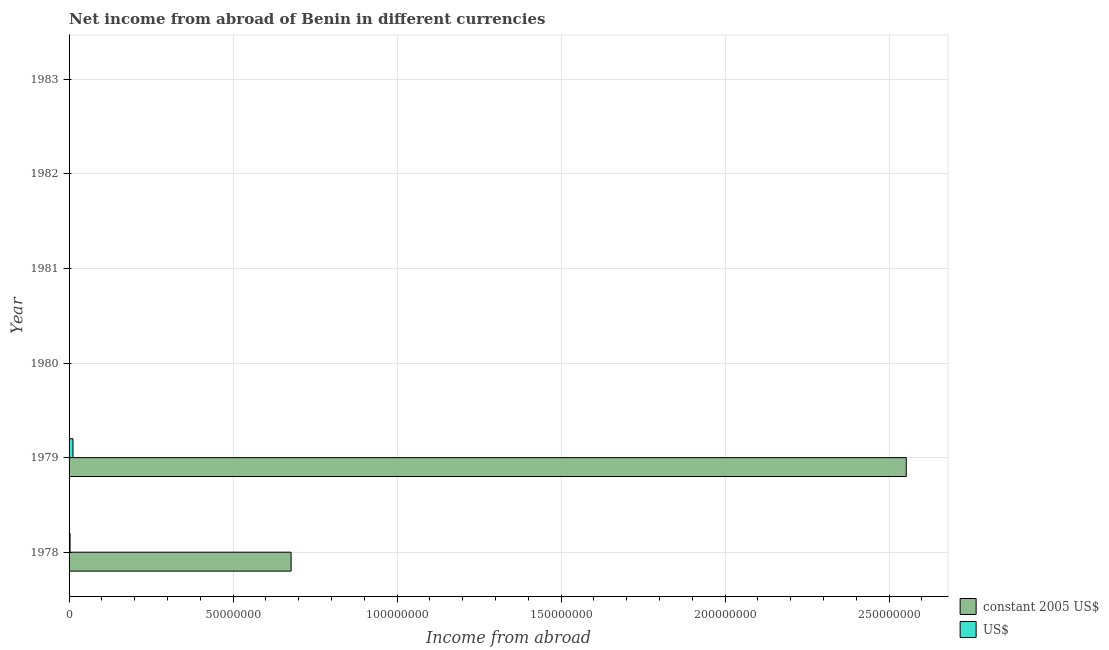Are the number of bars per tick equal to the number of legend labels?
Make the answer very short. No. Are the number of bars on each tick of the Y-axis equal?
Provide a short and direct response. No. How many bars are there on the 3rd tick from the top?
Your answer should be very brief. 0. How many bars are there on the 5th tick from the bottom?
Provide a succinct answer. 0. What is the label of the 6th group of bars from the top?
Your answer should be compact. 1978. In how many cases, is the number of bars for a given year not equal to the number of legend labels?
Make the answer very short. 4. What is the income from abroad in constant 2005 us$ in 1983?
Your answer should be very brief. 0. Across all years, what is the maximum income from abroad in constant 2005 us$?
Keep it short and to the point. 2.55e+08. Across all years, what is the minimum income from abroad in constant 2005 us$?
Your response must be concise. 0. In which year was the income from abroad in constant 2005 us$ maximum?
Provide a succinct answer. 1979. What is the total income from abroad in constant 2005 us$ in the graph?
Provide a short and direct response. 3.23e+08. What is the average income from abroad in constant 2005 us$ per year?
Offer a terse response. 5.38e+07. In the year 1979, what is the difference between the income from abroad in constant 2005 us$ and income from abroad in us$?
Provide a succinct answer. 2.54e+08. What is the ratio of the income from abroad in constant 2005 us$ in 1978 to that in 1979?
Make the answer very short. 0.27. What is the difference between the highest and the lowest income from abroad in us$?
Keep it short and to the point. 1.20e+06. How many years are there in the graph?
Give a very brief answer. 6. Does the graph contain any zero values?
Make the answer very short. Yes. Does the graph contain grids?
Offer a very short reply. Yes. Where does the legend appear in the graph?
Your answer should be very brief. Bottom right. How many legend labels are there?
Ensure brevity in your answer.  2. How are the legend labels stacked?
Offer a very short reply. Vertical. What is the title of the graph?
Make the answer very short. Net income from abroad of Benin in different currencies. What is the label or title of the X-axis?
Provide a succinct answer. Income from abroad. What is the Income from abroad of constant 2005 US$ in 1978?
Provide a short and direct response. 6.77e+07. What is the Income from abroad of US$ in 1978?
Offer a terse response. 3.00e+05. What is the Income from abroad in constant 2005 US$ in 1979?
Provide a succinct answer. 2.55e+08. What is the Income from abroad in US$ in 1979?
Offer a very short reply. 1.20e+06. What is the Income from abroad of constant 2005 US$ in 1981?
Offer a terse response. 0. What is the Income from abroad in US$ in 1981?
Your response must be concise. 0. What is the Income from abroad in constant 2005 US$ in 1982?
Your response must be concise. 0. What is the Income from abroad of US$ in 1983?
Make the answer very short. 0. Across all years, what is the maximum Income from abroad in constant 2005 US$?
Offer a very short reply. 2.55e+08. Across all years, what is the maximum Income from abroad of US$?
Offer a very short reply. 1.20e+06. What is the total Income from abroad of constant 2005 US$ in the graph?
Ensure brevity in your answer.  3.23e+08. What is the total Income from abroad in US$ in the graph?
Your response must be concise. 1.50e+06. What is the difference between the Income from abroad in constant 2005 US$ in 1978 and that in 1979?
Make the answer very short. -1.88e+08. What is the difference between the Income from abroad of US$ in 1978 and that in 1979?
Give a very brief answer. -9.00e+05. What is the difference between the Income from abroad of constant 2005 US$ in 1978 and the Income from abroad of US$ in 1979?
Keep it short and to the point. 6.65e+07. What is the average Income from abroad in constant 2005 US$ per year?
Offer a terse response. 5.38e+07. What is the average Income from abroad in US$ per year?
Ensure brevity in your answer.  2.50e+05. In the year 1978, what is the difference between the Income from abroad of constant 2005 US$ and Income from abroad of US$?
Make the answer very short. 6.74e+07. In the year 1979, what is the difference between the Income from abroad of constant 2005 US$ and Income from abroad of US$?
Your response must be concise. 2.54e+08. What is the ratio of the Income from abroad of constant 2005 US$ in 1978 to that in 1979?
Give a very brief answer. 0.27. What is the ratio of the Income from abroad of US$ in 1978 to that in 1979?
Provide a short and direct response. 0.25. What is the difference between the highest and the lowest Income from abroad in constant 2005 US$?
Offer a terse response. 2.55e+08. What is the difference between the highest and the lowest Income from abroad in US$?
Your response must be concise. 1.20e+06. 